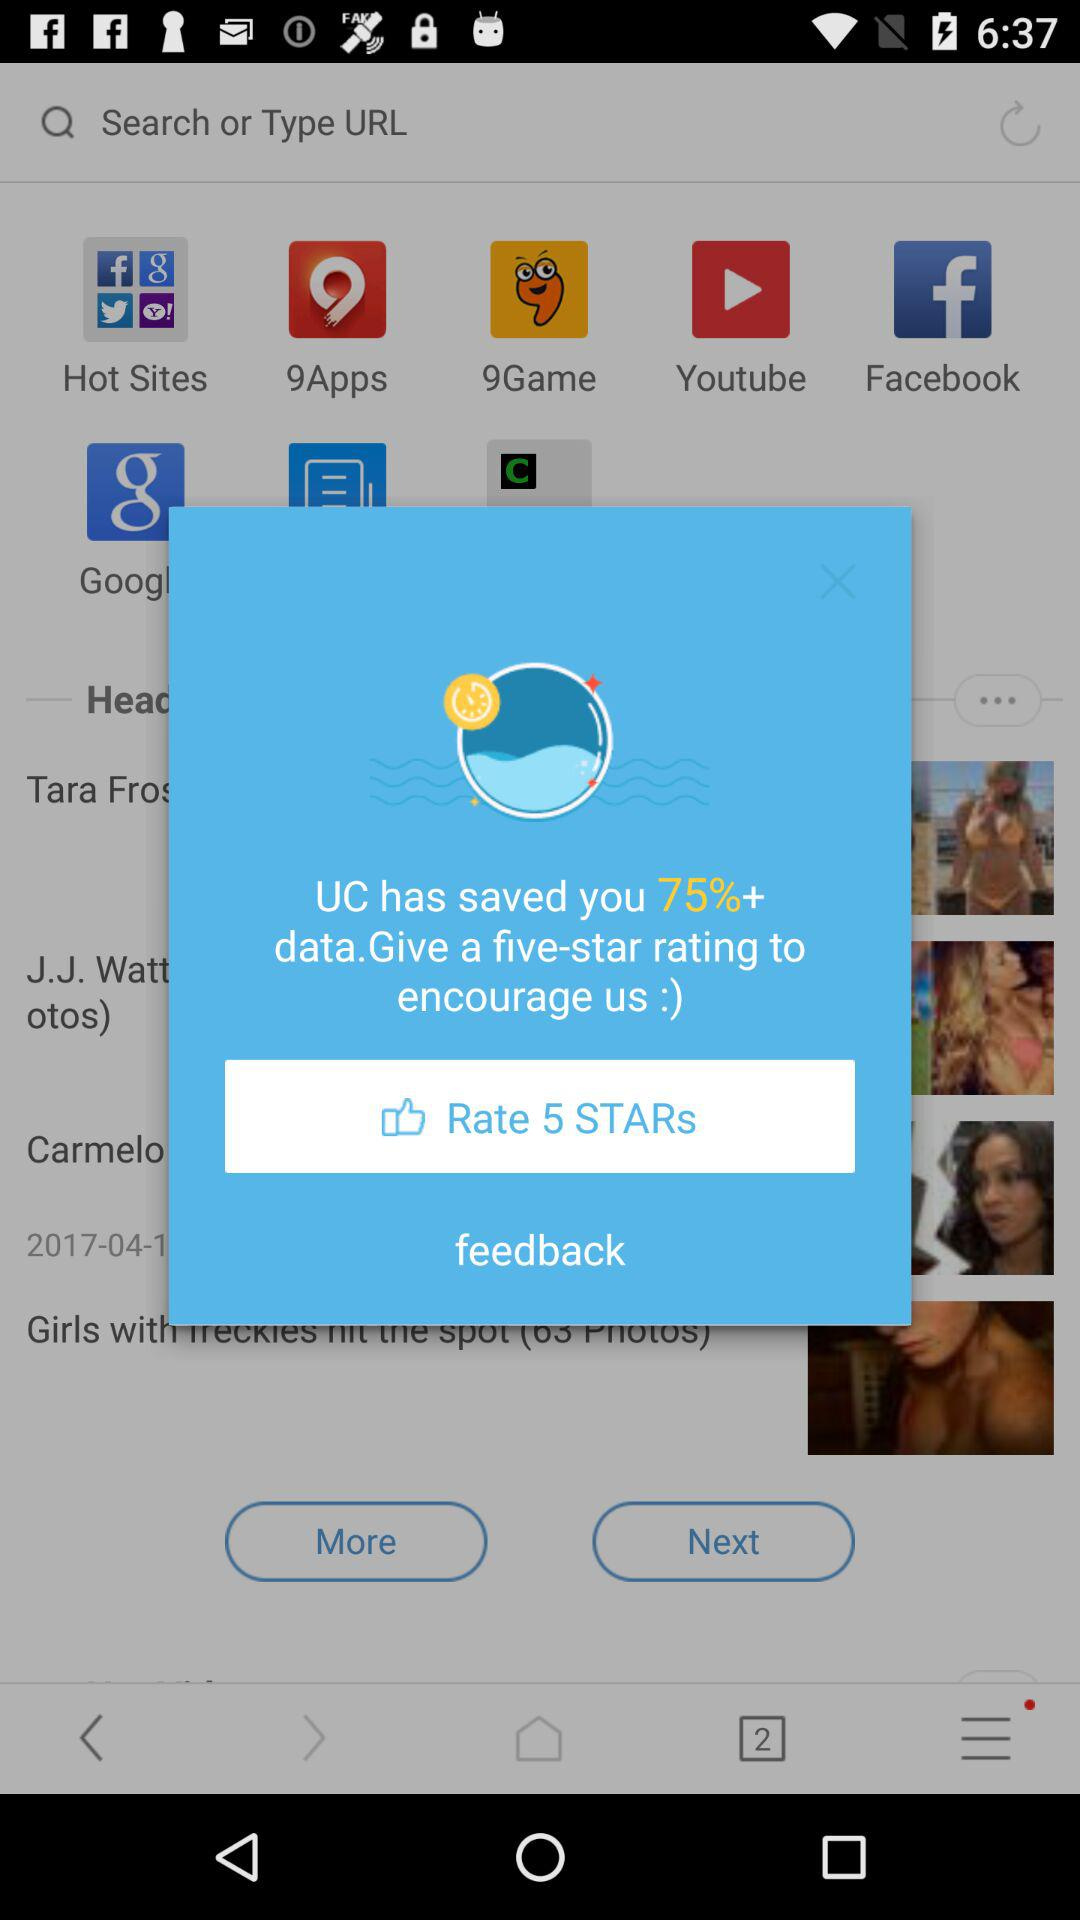How much data does UC save? UC saves more than 75% of the data. 